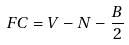<formula> <loc_0><loc_0><loc_500><loc_500>F C = V - N - \frac { B } { 2 }</formula> 